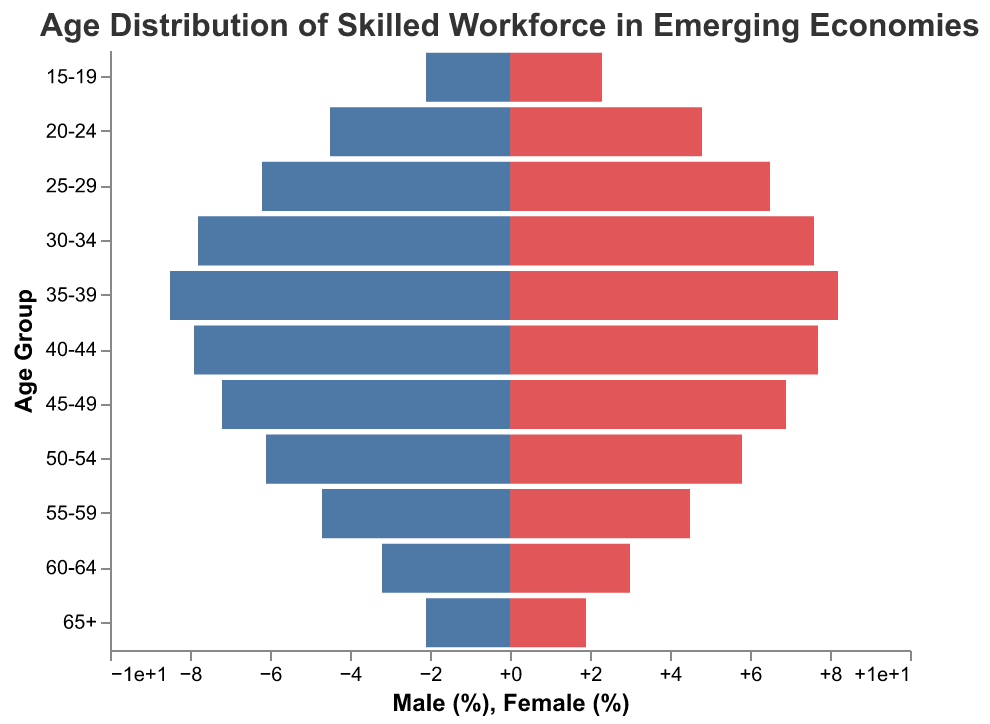What is the title of the figure? The title is displayed at the top of the figure and usually provides a summary of what the figure represents.
Answer: Age Distribution of Skilled Workforce in Emerging Economies What are the colors used for male and female in the bars? By visually inspecting the colors of the bars in the figure, we can see that males are represented by one color and females by another.
Answer: Males are blue, and females are red Which age group has the highest percentage of the female skilled workforce? By examining the heights of the red bars representing females, we see which one extends the farthest to the right.
Answer: 25-29 Which age group has the smallest representation for the male skilled workforce? By looking for the shortest blue bar on the left side of the figure, we can determine the smallest representation.
Answer: 15-19 and 65+ How do the percentages of males and females compare in the 35-39 age group? Compare the lengths of the bars for males and females in the 35-39 age group to see if they are equal, one is greater, or one is smaller.
Answer: Males (8.5%) have a greater percentage than females (8.2%) What is the combined percentage of males and females in the 60-64 age group? Add the percentages of males and females in the 60-64 age group: Male (3.2%) + Female (3.0%) = 6.2%
Answer: 6.2% Is there any age group where the percentage of females exceeds that of males? Compare the length of the bars for all age groups to identify if there are any age brackets where the red bar is longer than the blue one.
Answer: Yes, 15-19 and 20-24 Describe the trend in the distribution of the skilled workforce from 30-34 to 55-59 for both genders. Observe the bars' lengths for males and females in the 30-34 to 55-59 age groups to indicate whether they increase, decrease, or stabilize.
Answer: Males and females both peak around 35-39, then decrease steadily What is the percentage difference between males and females in the 50-54 age group? Subtract the percentage of females from the percentage of males in the 50-54 age group: Male (6.1%) - Female (5.8%) = 0.3%
Answer: 0.3% Among the age groups presented, which one has the closest percentage balance between males and females and what is the percentage difference? Look for the age group where the bars for males and females are nearly equal and calculate the difference: 30-34 age group: 7.8% (Males) - 7.6% (Females) = 0.2%
Answer: 30-34, 0.2% 